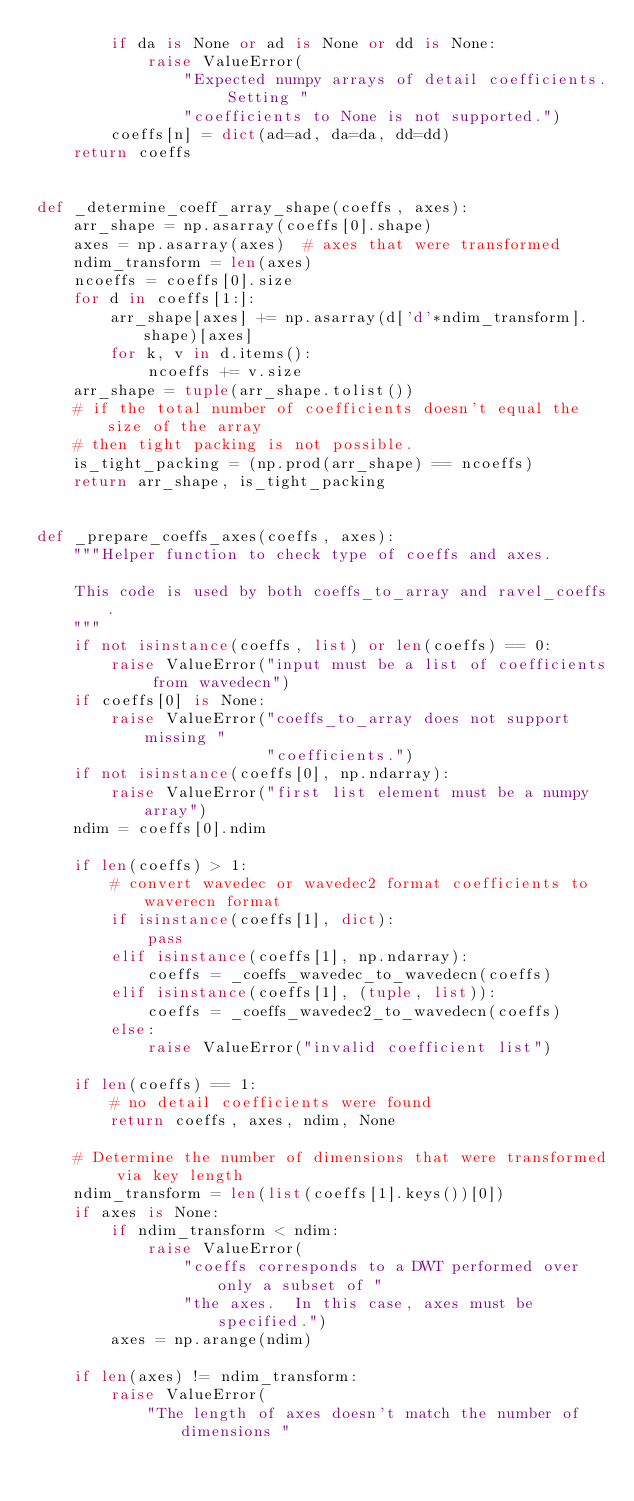Convert code to text. <code><loc_0><loc_0><loc_500><loc_500><_Python_>        if da is None or ad is None or dd is None:
            raise ValueError(
                "Expected numpy arrays of detail coefficients. Setting "
                "coefficients to None is not supported.")
        coeffs[n] = dict(ad=ad, da=da, dd=dd)
    return coeffs


def _determine_coeff_array_shape(coeffs, axes):
    arr_shape = np.asarray(coeffs[0].shape)
    axes = np.asarray(axes)  # axes that were transformed
    ndim_transform = len(axes)
    ncoeffs = coeffs[0].size
    for d in coeffs[1:]:
        arr_shape[axes] += np.asarray(d['d'*ndim_transform].shape)[axes]
        for k, v in d.items():
            ncoeffs += v.size
    arr_shape = tuple(arr_shape.tolist())
    # if the total number of coefficients doesn't equal the size of the array
    # then tight packing is not possible.
    is_tight_packing = (np.prod(arr_shape) == ncoeffs)
    return arr_shape, is_tight_packing


def _prepare_coeffs_axes(coeffs, axes):
    """Helper function to check type of coeffs and axes.

    This code is used by both coeffs_to_array and ravel_coeffs.
    """
    if not isinstance(coeffs, list) or len(coeffs) == 0:
        raise ValueError("input must be a list of coefficients from wavedecn")
    if coeffs[0] is None:
        raise ValueError("coeffs_to_array does not support missing "
                         "coefficients.")
    if not isinstance(coeffs[0], np.ndarray):
        raise ValueError("first list element must be a numpy array")
    ndim = coeffs[0].ndim

    if len(coeffs) > 1:
        # convert wavedec or wavedec2 format coefficients to waverecn format
        if isinstance(coeffs[1], dict):
            pass
        elif isinstance(coeffs[1], np.ndarray):
            coeffs = _coeffs_wavedec_to_wavedecn(coeffs)
        elif isinstance(coeffs[1], (tuple, list)):
            coeffs = _coeffs_wavedec2_to_wavedecn(coeffs)
        else:
            raise ValueError("invalid coefficient list")

    if len(coeffs) == 1:
        # no detail coefficients were found
        return coeffs, axes, ndim, None

    # Determine the number of dimensions that were transformed via key length
    ndim_transform = len(list(coeffs[1].keys())[0])
    if axes is None:
        if ndim_transform < ndim:
            raise ValueError(
                "coeffs corresponds to a DWT performed over only a subset of "
                "the axes.  In this case, axes must be specified.")
        axes = np.arange(ndim)

    if len(axes) != ndim_transform:
        raise ValueError(
            "The length of axes doesn't match the number of dimensions "</code> 